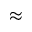<formula> <loc_0><loc_0><loc_500><loc_500>\approx</formula> 